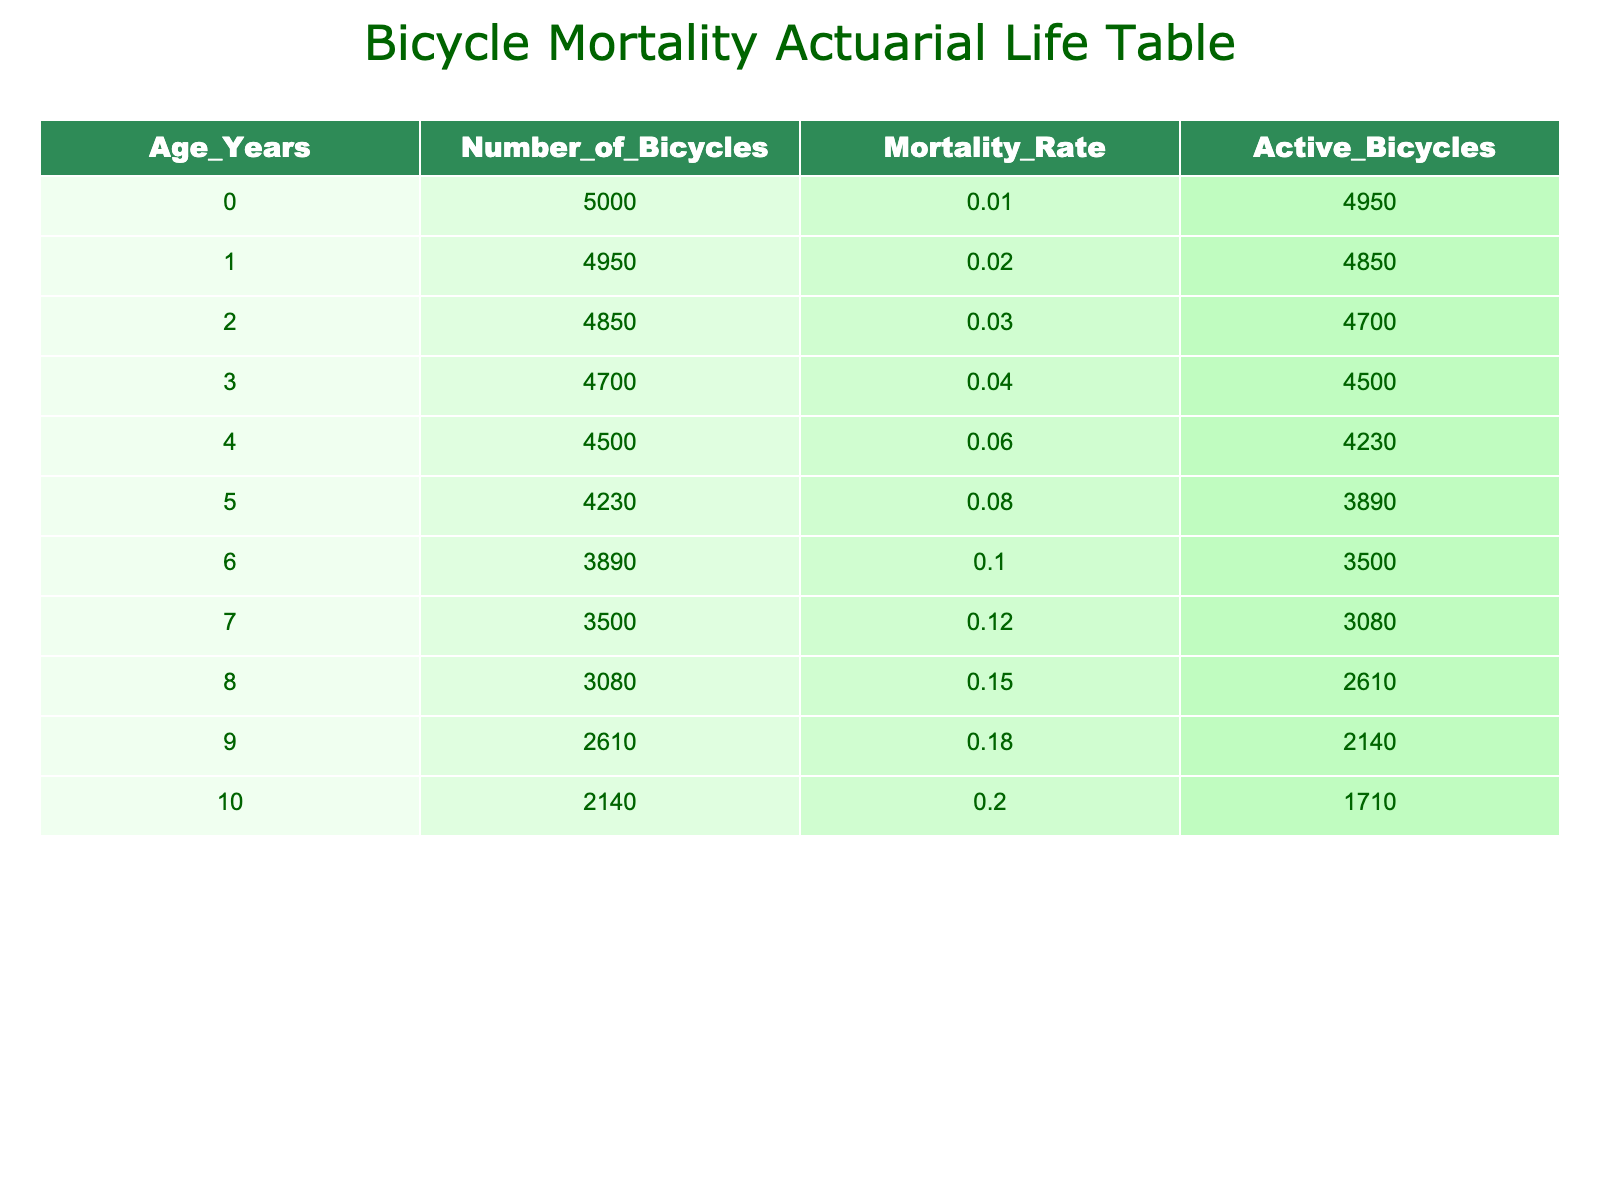What is the mortality rate for bicycles aged 5 years? By checking the table, we find the row corresponding to 5 years of age. The mortality rate listed there is 0.08.
Answer: 0.08 How many bicycles remain active after 3 years? In the table, we look at the number of active bicycles listed under the 3 years row, which shows 4500 bicycles remain active after 3 years.
Answer: 4500 What is the total number of bicycles that have reached the age of 10 years? The number of bicycles at the age of 10 years is directly listed in the table as 2140.
Answer: 2140 What is the average mortality rate of bicycles between the ages of 3 to 6 years? We first find the mortality rates for the ages of 3 (0.04), 4 (0.06), 5 (0.08), and 6 (0.10). Then, we sum these rates: 0.04 + 0.06 + 0.08 + 0.10 = 0.28. Finally, we divide by 4 (the number of ages) to find the average: 0.28 / 4 = 0.07.
Answer: 0.07 Is the mortality rate for bicycles increased from age 8 to age 9? We see that the mortality rate for bicycles at age 8 is 0.15 and at age 9 is 0.18. Since 0.18 is greater than 0.15, it confirms that the rate has increased.
Answer: Yes How many bicycles from the initial 5000 have been lost by the time they reach age 7? We start with 5000 bicycles and want to find how many are active by age 7. The number of active bicycles aged 7 years is 3500. So, the lost bicycles can be calculated as 5000 - 3500 = 1500.
Answer: 1500 What is the difference in the number of active bicycles between age 1 and age 10? The number of active bicycles is 4850 for age 1 and 1710 for age 10. The difference can be calculated as: 4850 - 1710 = 3140.
Answer: 3140 How many bicycles are active after the first five years? Looking at the table, the number of active bicycles after five years is listed as 3890.
Answer: 3890 Does the mortality rate increase uniformly with age? By reviewing the mortality rates from the table, we can see that they increase (0.01, 0.02, ..., 0.20) steadily as age increases. Hence, the statement holds true.
Answer: Yes 